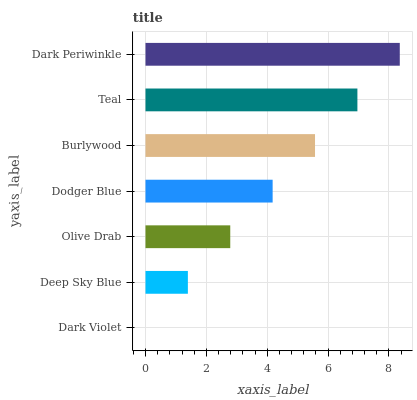Is Dark Violet the minimum?
Answer yes or no. Yes. Is Dark Periwinkle the maximum?
Answer yes or no. Yes. Is Deep Sky Blue the minimum?
Answer yes or no. No. Is Deep Sky Blue the maximum?
Answer yes or no. No. Is Deep Sky Blue greater than Dark Violet?
Answer yes or no. Yes. Is Dark Violet less than Deep Sky Blue?
Answer yes or no. Yes. Is Dark Violet greater than Deep Sky Blue?
Answer yes or no. No. Is Deep Sky Blue less than Dark Violet?
Answer yes or no. No. Is Dodger Blue the high median?
Answer yes or no. Yes. Is Dodger Blue the low median?
Answer yes or no. Yes. Is Burlywood the high median?
Answer yes or no. No. Is Deep Sky Blue the low median?
Answer yes or no. No. 